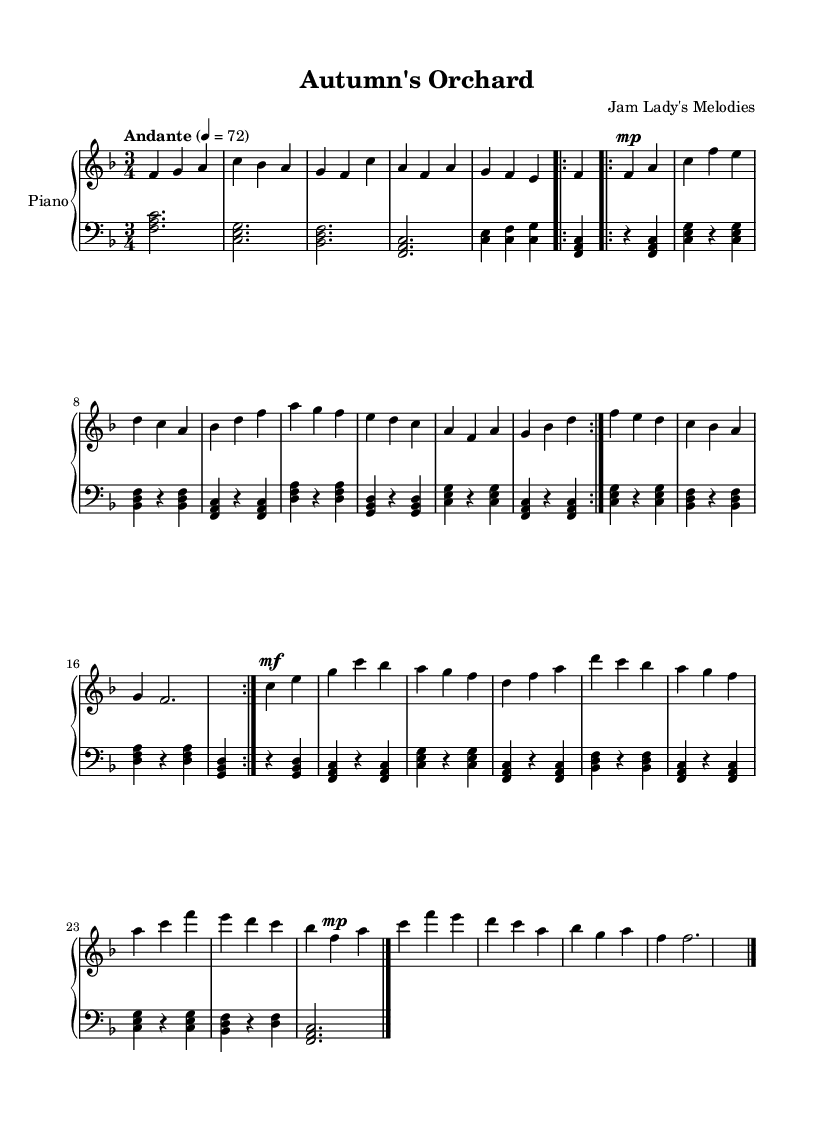What is the key signature of this music? The key signature is F major, which has one flat (B flat). You can determine the key signature by looking at the left side of the sheet music where the flats are indicated.
Answer: F major What is the time signature of the piece? The time signature is 3/4, which can be found at the beginning of the sheet music. This means there are three beats in each measure, and the quarter note gets one beat.
Answer: 3/4 What is the tempo marking for this piece? The tempo marking states "Andante" with a metronome marking of quarter note = 72. This indicates a moderate walking pace for the piece.
Answer: Andante, quarter note = 72 How many measures are repeated in the A section? The A section features a repeat sign at the beginning and is written to be repeated twice, comprising a total of two iterations of the same measures.
Answer: 2 What is the dynamic marking for the B section's opening measures? The B section starts with a marking of "mf," which indicates a mezzo forte dynamic, meaning moderately loud. This can be identified right above the notes in the sheet music where the B section begins.
Answer: mf What is the final chord that concludes the piece? The final chord is an F major chord, comprising the notes F, A, and C. This can be seen in the final measures of the sheet music where the piece concludes.
Answer: F major What theme does this piece represent? The title "Autumn's Orchard" suggests that the piece is inspired by the theme of autumn and nature. The seasonal reference is also reflected in the gentle melodies and harmonies.
Answer: Autumn 